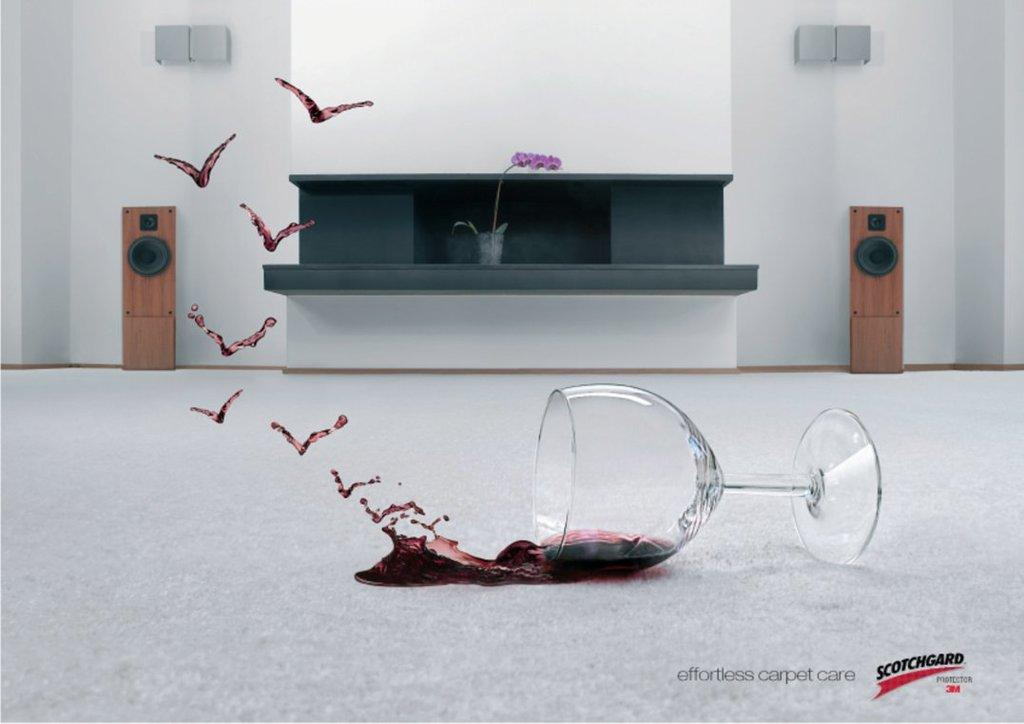What object is on the floor in the image? There is a glass on the floor. What can be seen in the background of the image? There is a wall, speakers, and a house plant in the background of the image. What type of plate is being used to brush the teeth in the image? There is no plate or teeth-brushing activity present in the image. 